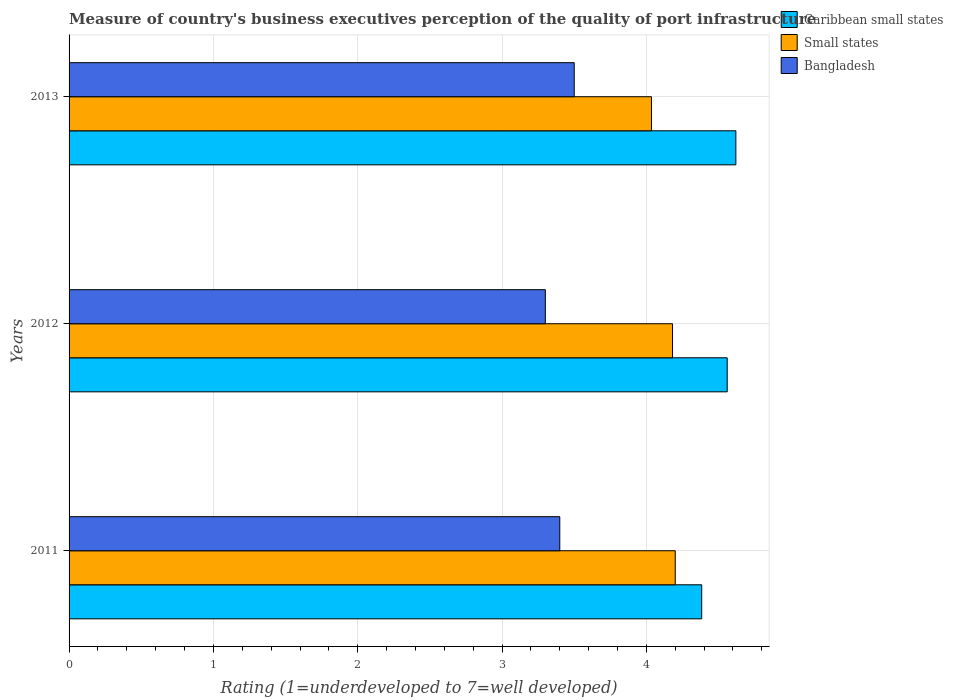How many different coloured bars are there?
Offer a very short reply. 3. How many groups of bars are there?
Give a very brief answer. 3. Are the number of bars on each tick of the Y-axis equal?
Provide a succinct answer. Yes. How many bars are there on the 2nd tick from the top?
Your answer should be very brief. 3. How many bars are there on the 3rd tick from the bottom?
Your response must be concise. 3. What is the label of the 3rd group of bars from the top?
Offer a very short reply. 2011. In how many cases, is the number of bars for a given year not equal to the number of legend labels?
Make the answer very short. 0. Across all years, what is the minimum ratings of the quality of port infrastructure in Bangladesh?
Provide a short and direct response. 3.3. In which year was the ratings of the quality of port infrastructure in Small states minimum?
Your answer should be very brief. 2013. What is the total ratings of the quality of port infrastructure in Bangladesh in the graph?
Offer a terse response. 10.2. What is the difference between the ratings of the quality of port infrastructure in Small states in 2011 and that in 2012?
Offer a very short reply. 0.02. What is the difference between the ratings of the quality of port infrastructure in Small states in 2013 and the ratings of the quality of port infrastructure in Bangladesh in 2012?
Offer a very short reply. 0.74. What is the average ratings of the quality of port infrastructure in Bangladesh per year?
Offer a terse response. 3.4. In the year 2013, what is the difference between the ratings of the quality of port infrastructure in Caribbean small states and ratings of the quality of port infrastructure in Bangladesh?
Provide a succinct answer. 1.12. In how many years, is the ratings of the quality of port infrastructure in Caribbean small states greater than 2.6 ?
Keep it short and to the point. 3. What is the ratio of the ratings of the quality of port infrastructure in Bangladesh in 2011 to that in 2012?
Your answer should be compact. 1.03. What is the difference between the highest and the second highest ratings of the quality of port infrastructure in Caribbean small states?
Make the answer very short. 0.06. What is the difference between the highest and the lowest ratings of the quality of port infrastructure in Bangladesh?
Your answer should be compact. 0.2. In how many years, is the ratings of the quality of port infrastructure in Bangladesh greater than the average ratings of the quality of port infrastructure in Bangladesh taken over all years?
Your answer should be compact. 1. What does the 1st bar from the bottom in 2012 represents?
Ensure brevity in your answer.  Caribbean small states. How many bars are there?
Keep it short and to the point. 9. Are all the bars in the graph horizontal?
Give a very brief answer. Yes. What is the difference between two consecutive major ticks on the X-axis?
Provide a succinct answer. 1. What is the title of the graph?
Make the answer very short. Measure of country's business executives perception of the quality of port infrastructure. Does "Netherlands" appear as one of the legend labels in the graph?
Your answer should be compact. No. What is the label or title of the X-axis?
Offer a terse response. Rating (1=underdeveloped to 7=well developed). What is the Rating (1=underdeveloped to 7=well developed) in Caribbean small states in 2011?
Provide a short and direct response. 4.38. What is the Rating (1=underdeveloped to 7=well developed) in Small states in 2011?
Give a very brief answer. 4.2. What is the Rating (1=underdeveloped to 7=well developed) of Bangladesh in 2011?
Provide a short and direct response. 3.4. What is the Rating (1=underdeveloped to 7=well developed) in Caribbean small states in 2012?
Give a very brief answer. 4.56. What is the Rating (1=underdeveloped to 7=well developed) in Small states in 2012?
Your response must be concise. 4.18. What is the Rating (1=underdeveloped to 7=well developed) in Caribbean small states in 2013?
Ensure brevity in your answer.  4.62. What is the Rating (1=underdeveloped to 7=well developed) of Small states in 2013?
Ensure brevity in your answer.  4.04. What is the Rating (1=underdeveloped to 7=well developed) in Bangladesh in 2013?
Give a very brief answer. 3.5. Across all years, what is the maximum Rating (1=underdeveloped to 7=well developed) in Caribbean small states?
Your response must be concise. 4.62. Across all years, what is the minimum Rating (1=underdeveloped to 7=well developed) in Caribbean small states?
Keep it short and to the point. 4.38. Across all years, what is the minimum Rating (1=underdeveloped to 7=well developed) in Small states?
Ensure brevity in your answer.  4.04. What is the total Rating (1=underdeveloped to 7=well developed) in Caribbean small states in the graph?
Offer a very short reply. 13.56. What is the total Rating (1=underdeveloped to 7=well developed) in Small states in the graph?
Offer a terse response. 12.42. What is the difference between the Rating (1=underdeveloped to 7=well developed) in Caribbean small states in 2011 and that in 2012?
Provide a succinct answer. -0.18. What is the difference between the Rating (1=underdeveloped to 7=well developed) in Small states in 2011 and that in 2012?
Your response must be concise. 0.02. What is the difference between the Rating (1=underdeveloped to 7=well developed) of Bangladesh in 2011 and that in 2012?
Offer a very short reply. 0.1. What is the difference between the Rating (1=underdeveloped to 7=well developed) of Caribbean small states in 2011 and that in 2013?
Your answer should be very brief. -0.24. What is the difference between the Rating (1=underdeveloped to 7=well developed) of Small states in 2011 and that in 2013?
Provide a succinct answer. 0.16. What is the difference between the Rating (1=underdeveloped to 7=well developed) in Bangladesh in 2011 and that in 2013?
Keep it short and to the point. -0.1. What is the difference between the Rating (1=underdeveloped to 7=well developed) in Caribbean small states in 2012 and that in 2013?
Keep it short and to the point. -0.06. What is the difference between the Rating (1=underdeveloped to 7=well developed) in Small states in 2012 and that in 2013?
Provide a short and direct response. 0.15. What is the difference between the Rating (1=underdeveloped to 7=well developed) of Bangladesh in 2012 and that in 2013?
Provide a succinct answer. -0.2. What is the difference between the Rating (1=underdeveloped to 7=well developed) of Caribbean small states in 2011 and the Rating (1=underdeveloped to 7=well developed) of Small states in 2012?
Your answer should be compact. 0.2. What is the difference between the Rating (1=underdeveloped to 7=well developed) of Caribbean small states in 2011 and the Rating (1=underdeveloped to 7=well developed) of Bangladesh in 2012?
Provide a short and direct response. 1.08. What is the difference between the Rating (1=underdeveloped to 7=well developed) in Small states in 2011 and the Rating (1=underdeveloped to 7=well developed) in Bangladesh in 2012?
Ensure brevity in your answer.  0.9. What is the difference between the Rating (1=underdeveloped to 7=well developed) in Caribbean small states in 2011 and the Rating (1=underdeveloped to 7=well developed) in Small states in 2013?
Offer a terse response. 0.35. What is the difference between the Rating (1=underdeveloped to 7=well developed) of Caribbean small states in 2011 and the Rating (1=underdeveloped to 7=well developed) of Bangladesh in 2013?
Your response must be concise. 0.88. What is the difference between the Rating (1=underdeveloped to 7=well developed) in Caribbean small states in 2012 and the Rating (1=underdeveloped to 7=well developed) in Small states in 2013?
Keep it short and to the point. 0.52. What is the difference between the Rating (1=underdeveloped to 7=well developed) of Caribbean small states in 2012 and the Rating (1=underdeveloped to 7=well developed) of Bangladesh in 2013?
Keep it short and to the point. 1.06. What is the difference between the Rating (1=underdeveloped to 7=well developed) in Small states in 2012 and the Rating (1=underdeveloped to 7=well developed) in Bangladesh in 2013?
Provide a short and direct response. 0.68. What is the average Rating (1=underdeveloped to 7=well developed) of Caribbean small states per year?
Ensure brevity in your answer.  4.52. What is the average Rating (1=underdeveloped to 7=well developed) of Small states per year?
Offer a very short reply. 4.14. In the year 2011, what is the difference between the Rating (1=underdeveloped to 7=well developed) in Caribbean small states and Rating (1=underdeveloped to 7=well developed) in Small states?
Your response must be concise. 0.18. In the year 2011, what is the difference between the Rating (1=underdeveloped to 7=well developed) of Caribbean small states and Rating (1=underdeveloped to 7=well developed) of Bangladesh?
Your answer should be very brief. 0.98. In the year 2012, what is the difference between the Rating (1=underdeveloped to 7=well developed) in Caribbean small states and Rating (1=underdeveloped to 7=well developed) in Small states?
Offer a very short reply. 0.38. In the year 2012, what is the difference between the Rating (1=underdeveloped to 7=well developed) of Caribbean small states and Rating (1=underdeveloped to 7=well developed) of Bangladesh?
Keep it short and to the point. 1.26. In the year 2012, what is the difference between the Rating (1=underdeveloped to 7=well developed) of Small states and Rating (1=underdeveloped to 7=well developed) of Bangladesh?
Your answer should be very brief. 0.88. In the year 2013, what is the difference between the Rating (1=underdeveloped to 7=well developed) of Caribbean small states and Rating (1=underdeveloped to 7=well developed) of Small states?
Provide a short and direct response. 0.58. In the year 2013, what is the difference between the Rating (1=underdeveloped to 7=well developed) of Caribbean small states and Rating (1=underdeveloped to 7=well developed) of Bangladesh?
Keep it short and to the point. 1.12. In the year 2013, what is the difference between the Rating (1=underdeveloped to 7=well developed) of Small states and Rating (1=underdeveloped to 7=well developed) of Bangladesh?
Offer a terse response. 0.54. What is the ratio of the Rating (1=underdeveloped to 7=well developed) in Caribbean small states in 2011 to that in 2012?
Your answer should be very brief. 0.96. What is the ratio of the Rating (1=underdeveloped to 7=well developed) of Bangladesh in 2011 to that in 2012?
Your answer should be compact. 1.03. What is the ratio of the Rating (1=underdeveloped to 7=well developed) in Caribbean small states in 2011 to that in 2013?
Provide a succinct answer. 0.95. What is the ratio of the Rating (1=underdeveloped to 7=well developed) in Small states in 2011 to that in 2013?
Offer a very short reply. 1.04. What is the ratio of the Rating (1=underdeveloped to 7=well developed) of Bangladesh in 2011 to that in 2013?
Your response must be concise. 0.97. What is the ratio of the Rating (1=underdeveloped to 7=well developed) of Small states in 2012 to that in 2013?
Your answer should be very brief. 1.04. What is the ratio of the Rating (1=underdeveloped to 7=well developed) in Bangladesh in 2012 to that in 2013?
Provide a short and direct response. 0.94. What is the difference between the highest and the second highest Rating (1=underdeveloped to 7=well developed) in Small states?
Your answer should be very brief. 0.02. What is the difference between the highest and the second highest Rating (1=underdeveloped to 7=well developed) in Bangladesh?
Provide a short and direct response. 0.1. What is the difference between the highest and the lowest Rating (1=underdeveloped to 7=well developed) of Caribbean small states?
Your response must be concise. 0.24. What is the difference between the highest and the lowest Rating (1=underdeveloped to 7=well developed) of Small states?
Make the answer very short. 0.16. What is the difference between the highest and the lowest Rating (1=underdeveloped to 7=well developed) of Bangladesh?
Your answer should be very brief. 0.2. 